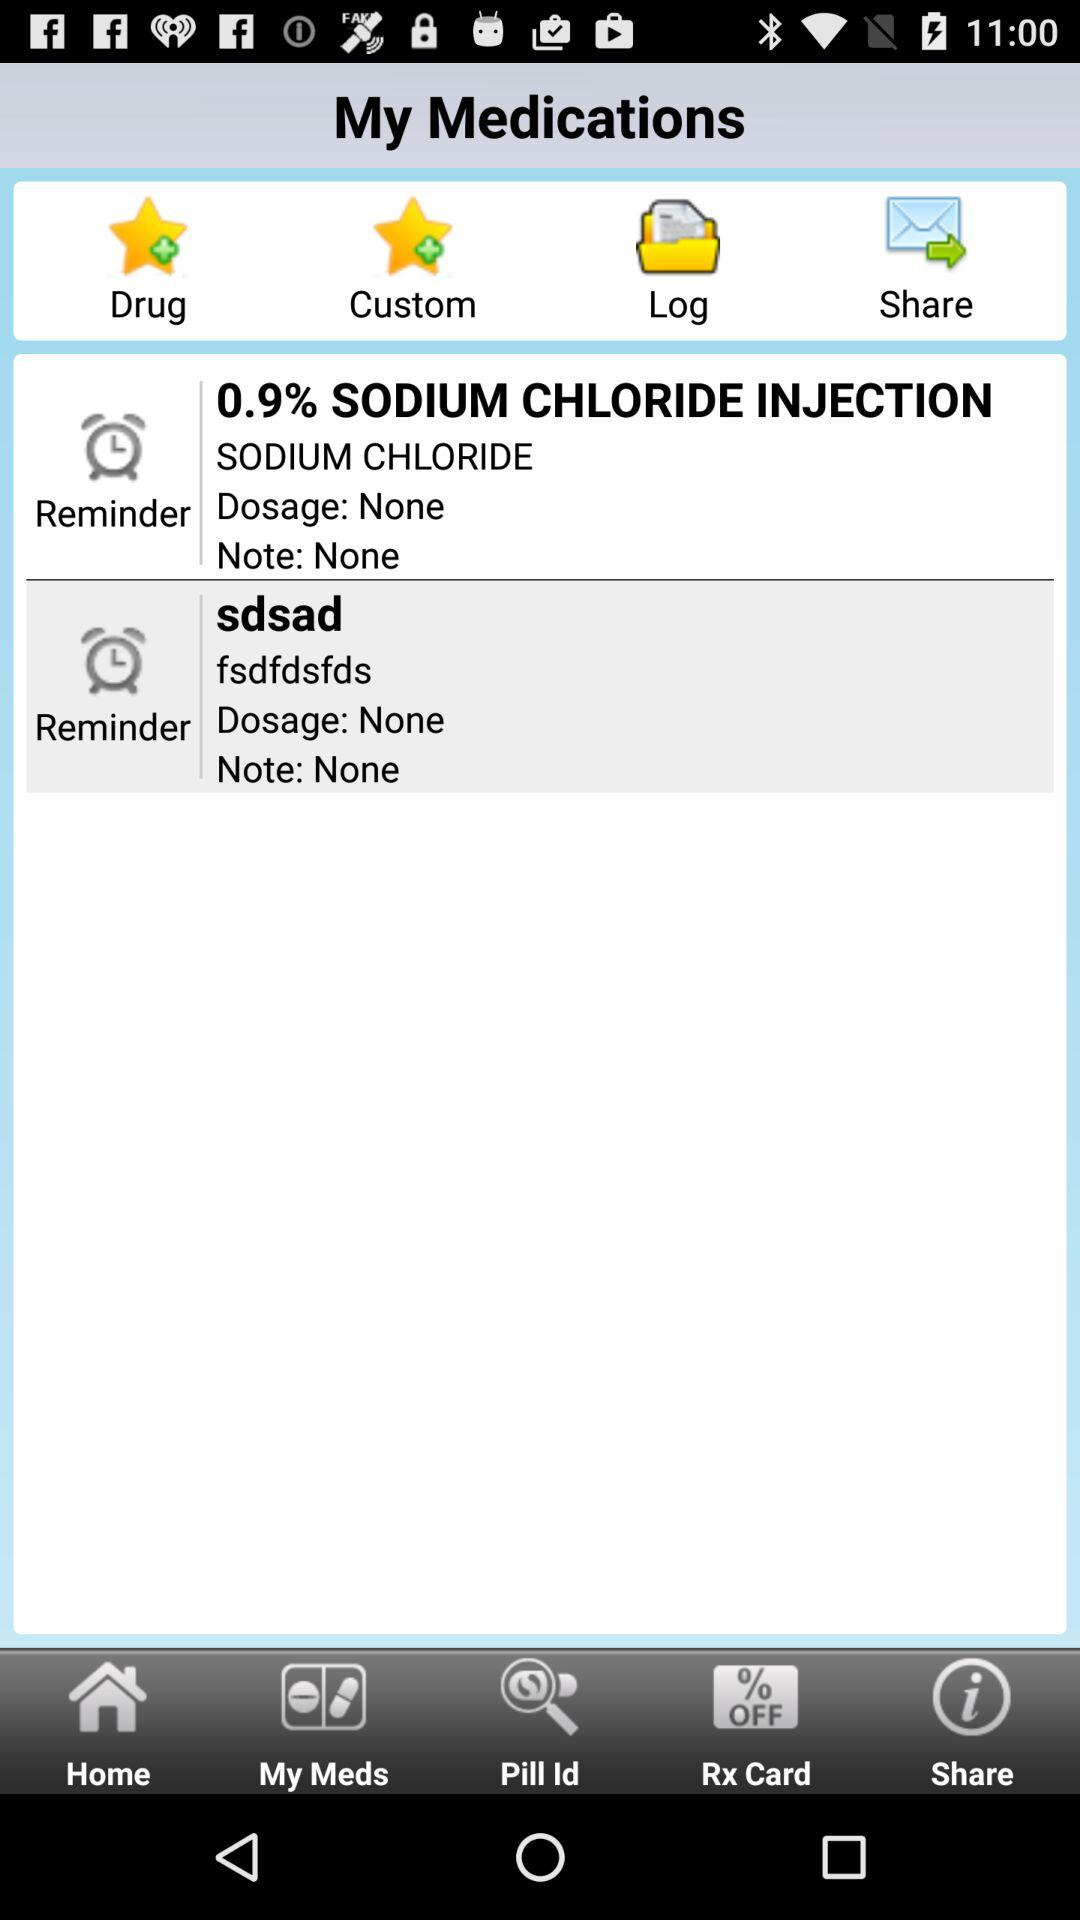Which option is selected? The selected option is "sdsad". 